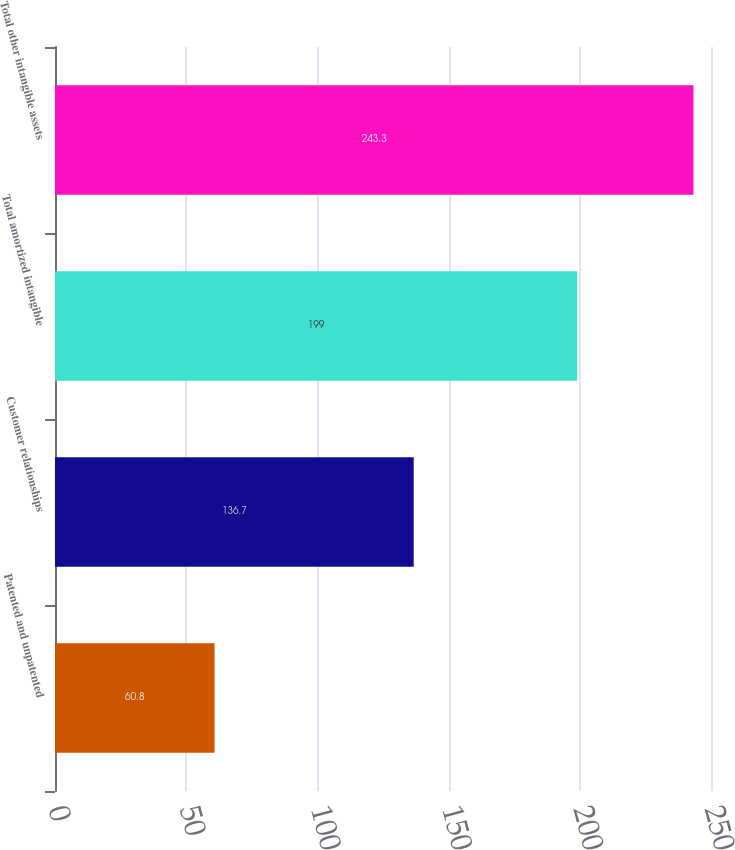Convert chart to OTSL. <chart><loc_0><loc_0><loc_500><loc_500><bar_chart><fcel>Patented and unpatented<fcel>Customer relationships<fcel>Total amortized intangible<fcel>Total other intangible assets<nl><fcel>60.8<fcel>136.7<fcel>199<fcel>243.3<nl></chart> 